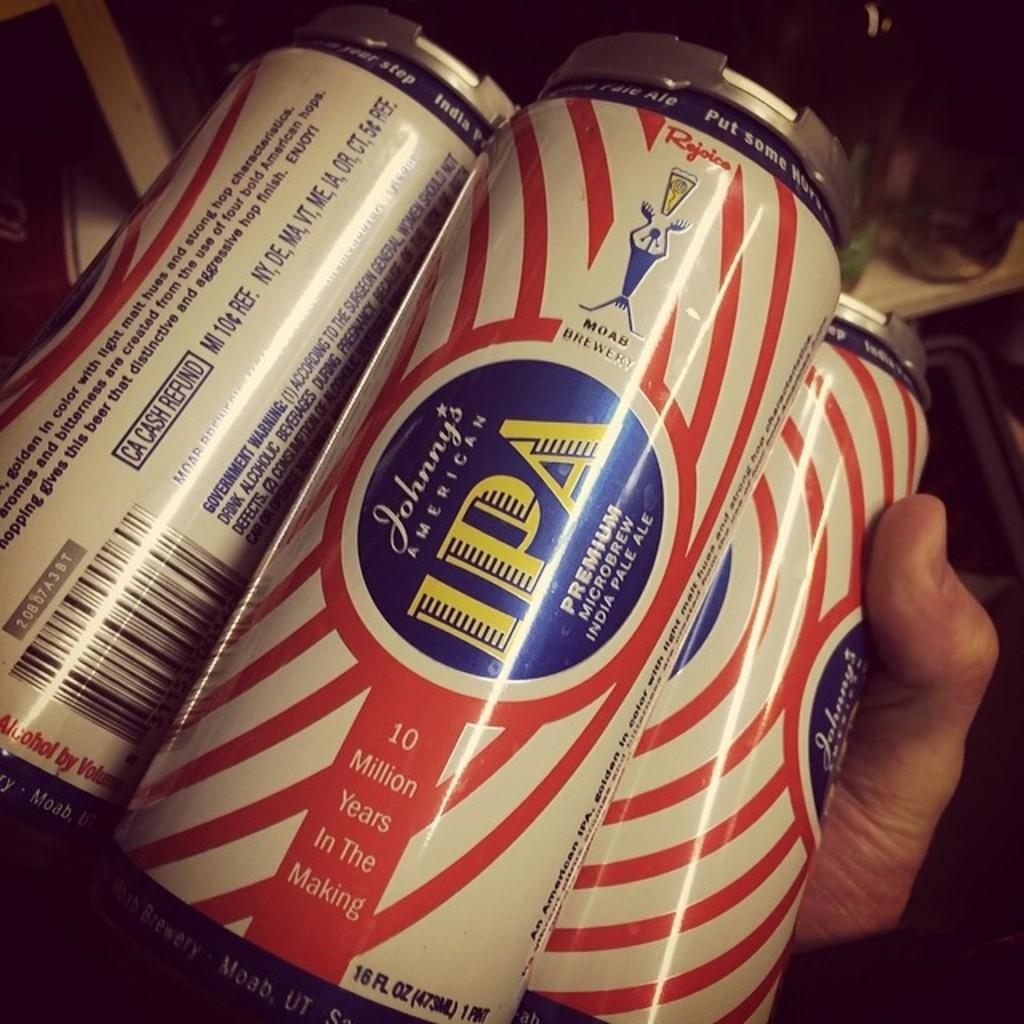Who or what is present in the image? There is a person in the image. What is the person holding in their hand? The person is holding three tins in their hand. Can you describe the tins in more detail? There is text written on the tins. How does the person feel about the comfort of the crowd in the territory depicted in the image? There is no crowd, comfort, or territory mentioned or depicted in the image. The image only shows a person holding three tins with text written on them. 